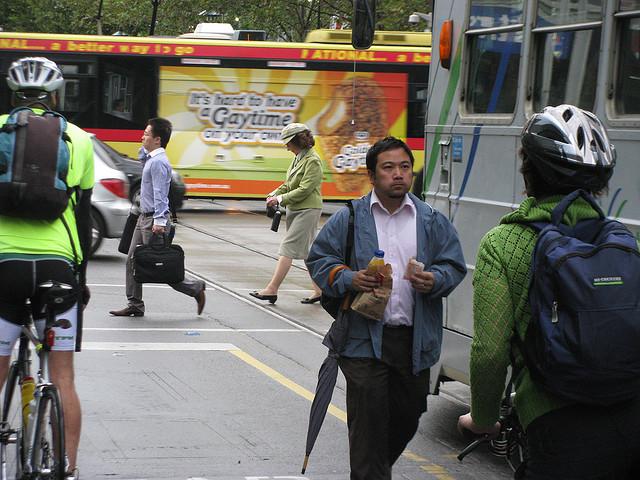How many people are in the photo?
Write a very short answer. 5. What is the color of the boys helmets?
Keep it brief. Silver. Is the man sleeping?
Quick response, please. No. Is it hot outside?
Keep it brief. No. How many bicycles are in the picture?
Write a very short answer. 2. What type of ad is on the bus?
Quick response, please. Ice cream. How many umbrellas are in this picture?
Concise answer only. 1. Are they wearing helmets?
Be succinct. Yes. 